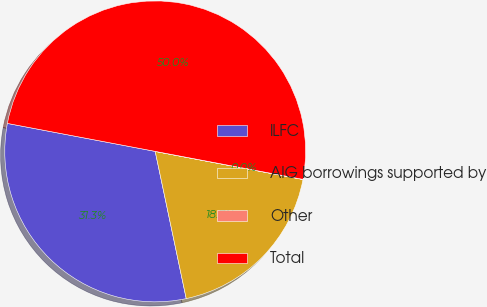Convert chart. <chart><loc_0><loc_0><loc_500><loc_500><pie_chart><fcel>ILFC<fcel>AIG borrowings supported by<fcel>Other<fcel>Total<nl><fcel>31.28%<fcel>18.7%<fcel>0.01%<fcel>50.0%<nl></chart> 